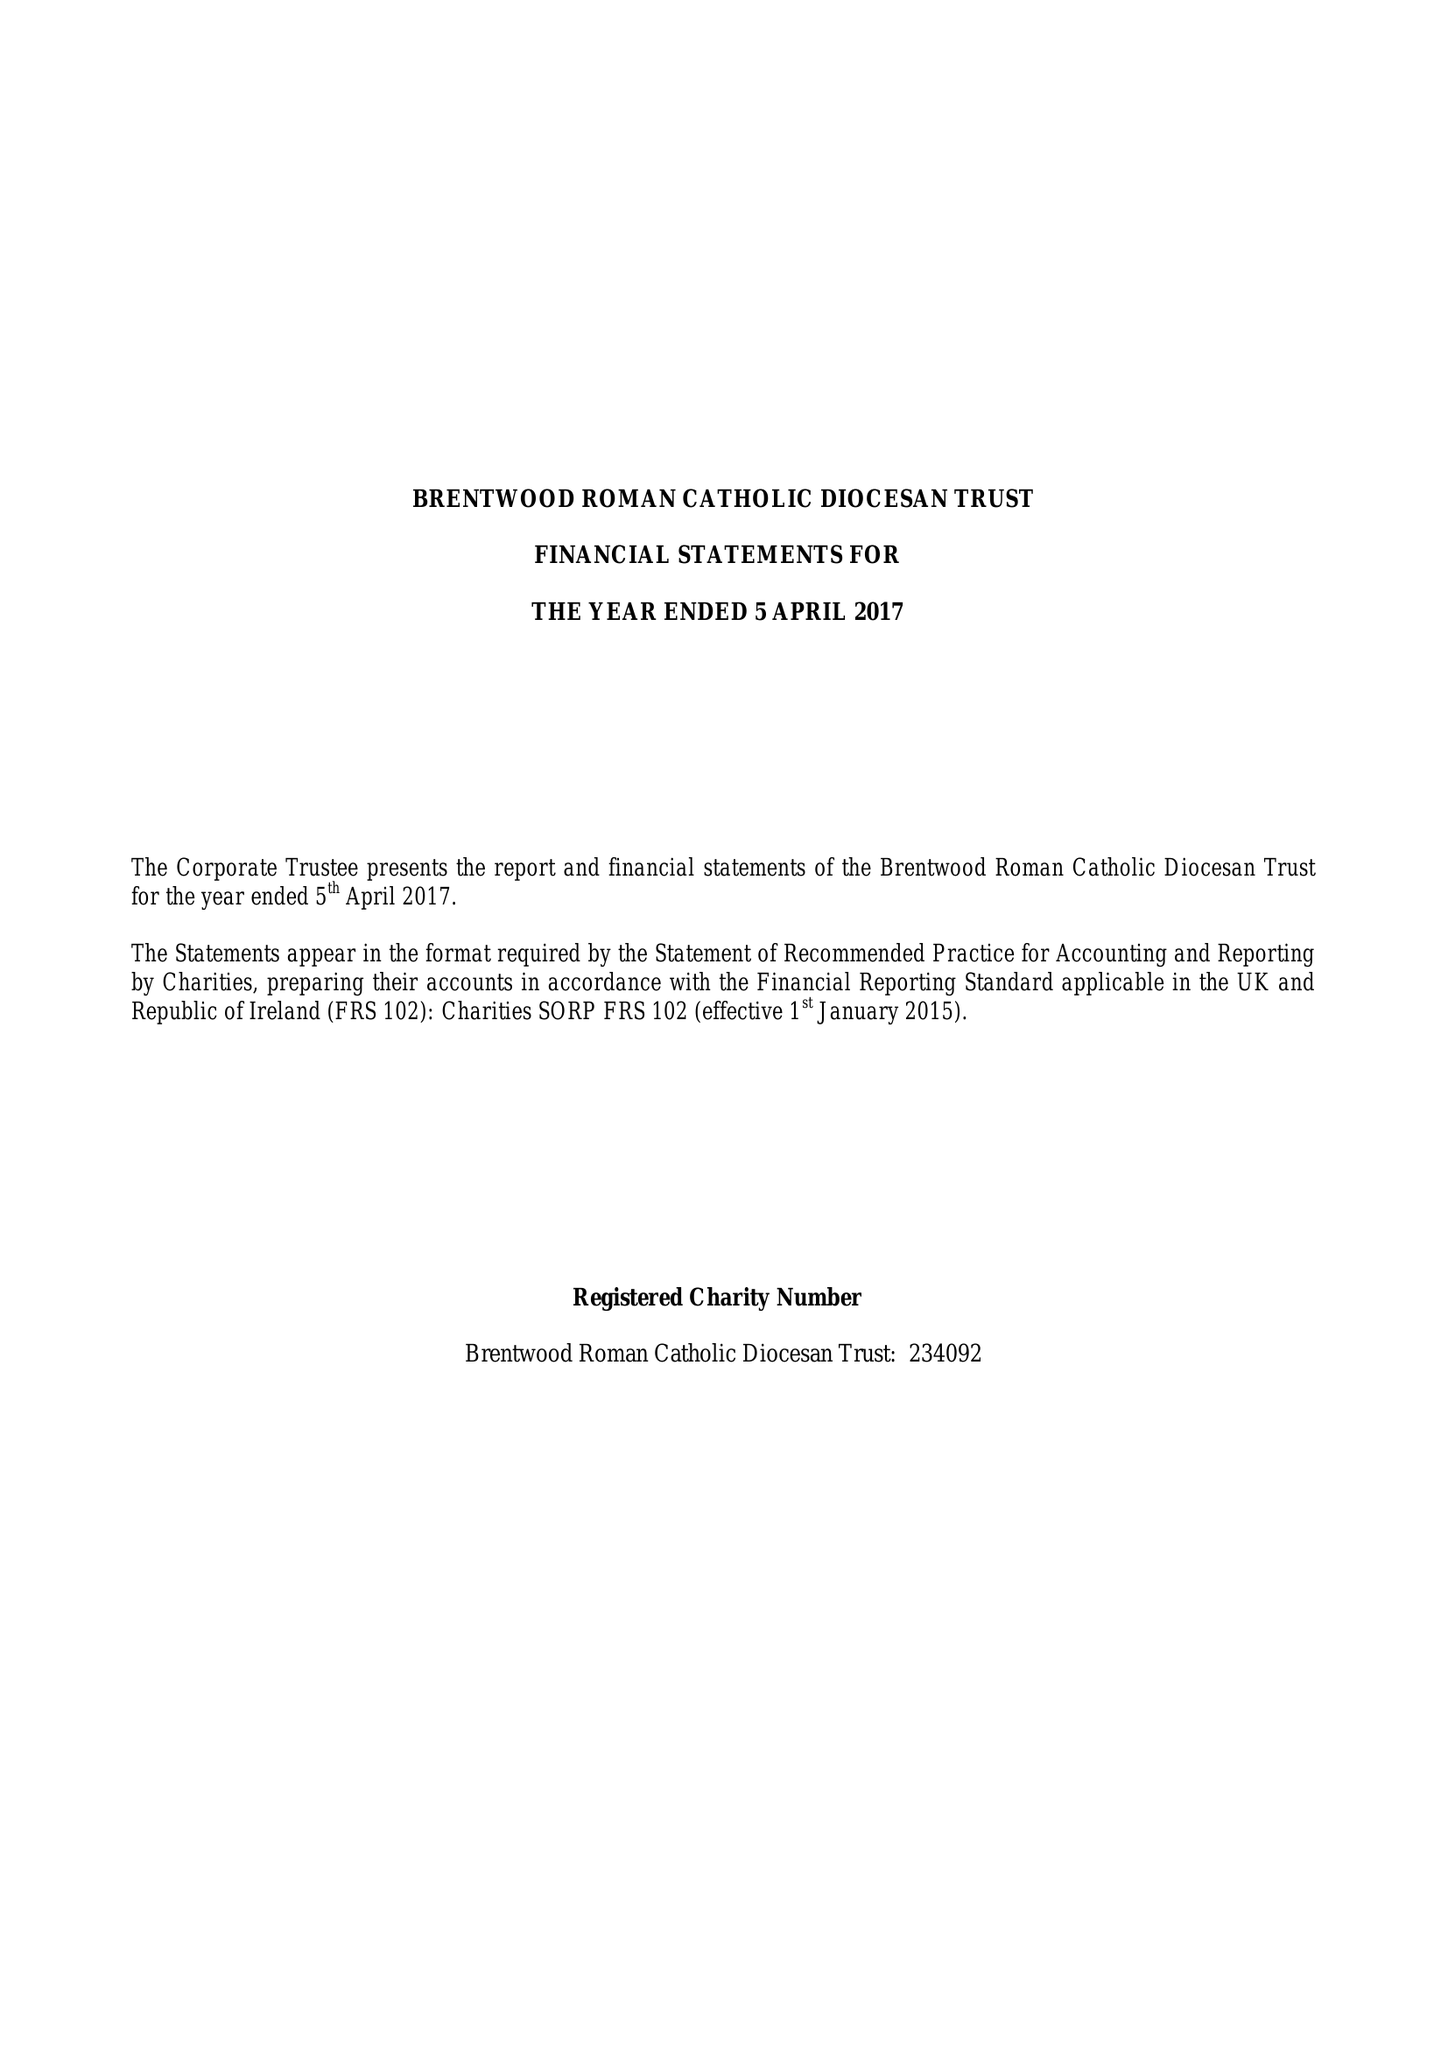What is the value for the charity_number?
Answer the question using a single word or phrase. 234092 